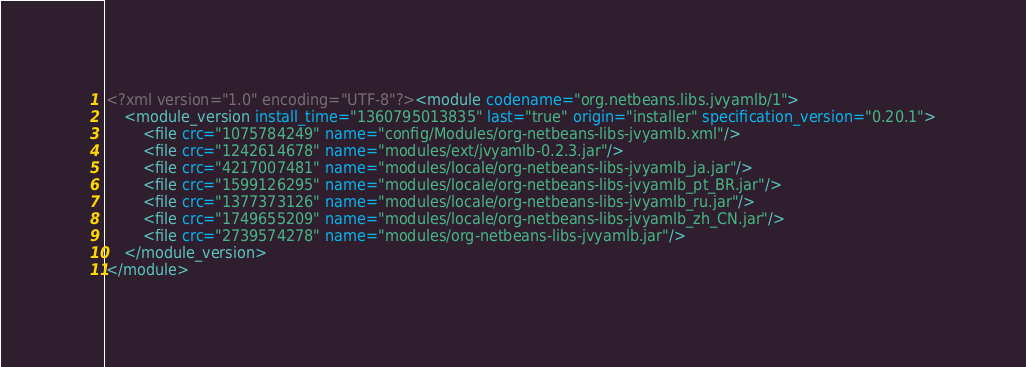Convert code to text. <code><loc_0><loc_0><loc_500><loc_500><_XML_><?xml version="1.0" encoding="UTF-8"?><module codename="org.netbeans.libs.jvyamlb/1">
    <module_version install_time="1360795013835" last="true" origin="installer" specification_version="0.20.1">
        <file crc="1075784249" name="config/Modules/org-netbeans-libs-jvyamlb.xml"/>
        <file crc="1242614678" name="modules/ext/jvyamlb-0.2.3.jar"/>
        <file crc="4217007481" name="modules/locale/org-netbeans-libs-jvyamlb_ja.jar"/>
        <file crc="1599126295" name="modules/locale/org-netbeans-libs-jvyamlb_pt_BR.jar"/>
        <file crc="1377373126" name="modules/locale/org-netbeans-libs-jvyamlb_ru.jar"/>
        <file crc="1749655209" name="modules/locale/org-netbeans-libs-jvyamlb_zh_CN.jar"/>
        <file crc="2739574278" name="modules/org-netbeans-libs-jvyamlb.jar"/>
    </module_version>
</module>
</code> 